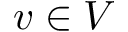<formula> <loc_0><loc_0><loc_500><loc_500>v \in V</formula> 